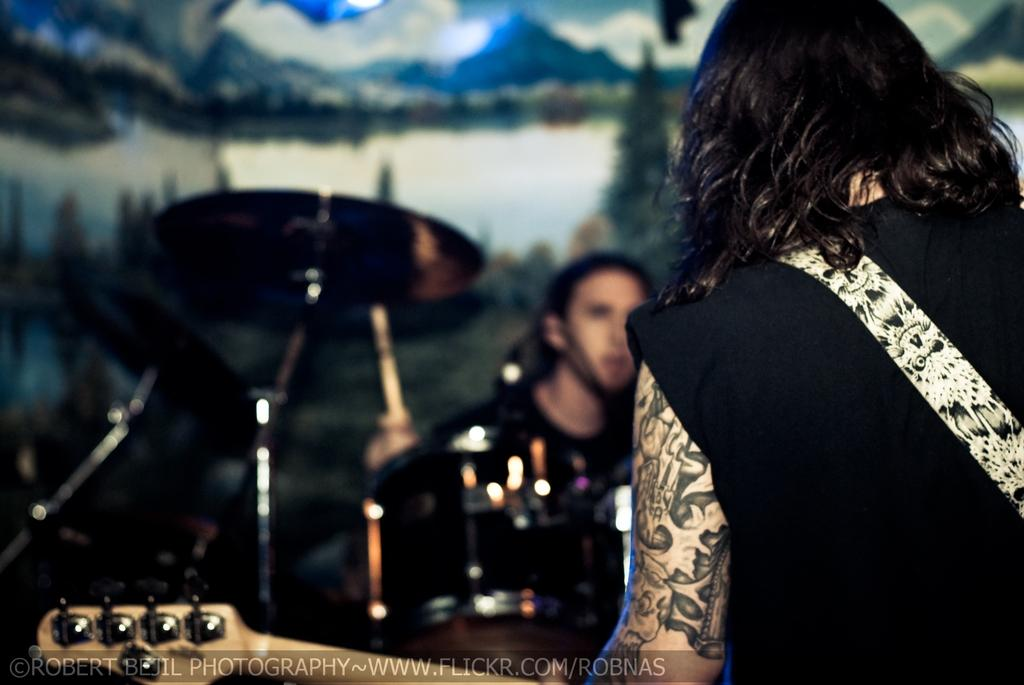What is the main subject of the image? There is a person in the image. What is the person holding in the image? The person is holding a guitar. Are there any other musical instruments in the image besides the guitar? Yes, there are musical instruments in the image. What type of pet can be seen sitting next to the person in the image? There is no pet visible in the image; it only features a person holding a guitar and other musical instruments. 